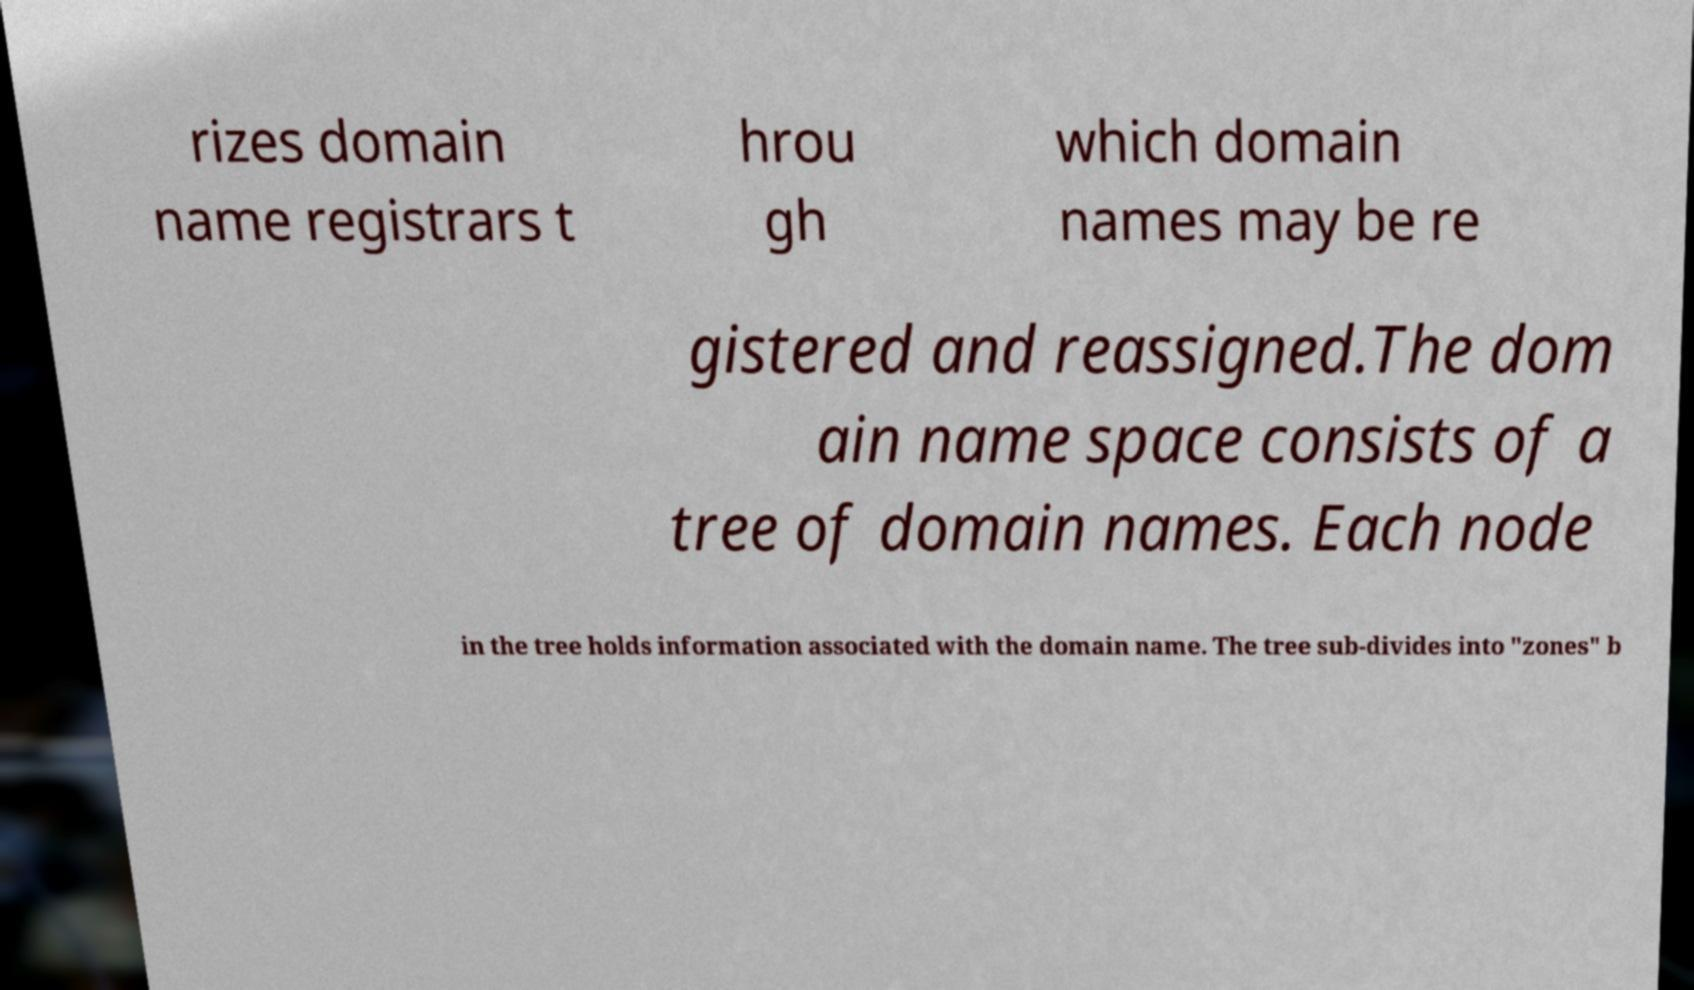Please read and relay the text visible in this image. What does it say? rizes domain name registrars t hrou gh which domain names may be re gistered and reassigned.The dom ain name space consists of a tree of domain names. Each node in the tree holds information associated with the domain name. The tree sub-divides into "zones" b 